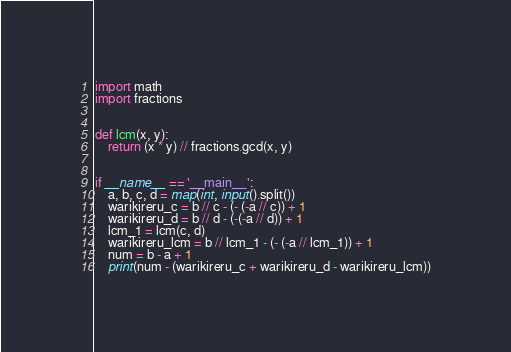<code> <loc_0><loc_0><loc_500><loc_500><_Python_>import math
import fractions


def lcm(x, y):
    return (x * y) // fractions.gcd(x, y)


if __name__ == '__main__':
    a, b, c, d = map(int, input().split())
    warikireru_c = b // c - (- (-a // c)) + 1
    warikireru_d = b // d - (-(-a // d)) + 1
    lcm_1 = lcm(c, d)
    warikireru_lcm = b // lcm_1 - (- (-a // lcm_1)) + 1
    num = b - a + 1
    print(num - (warikireru_c + warikireru_d - warikireru_lcm))
</code> 